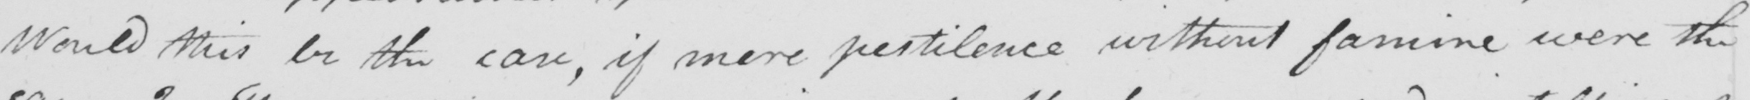Please transcribe the handwritten text in this image. Would this be the case , if mere pestilence without famine were the 